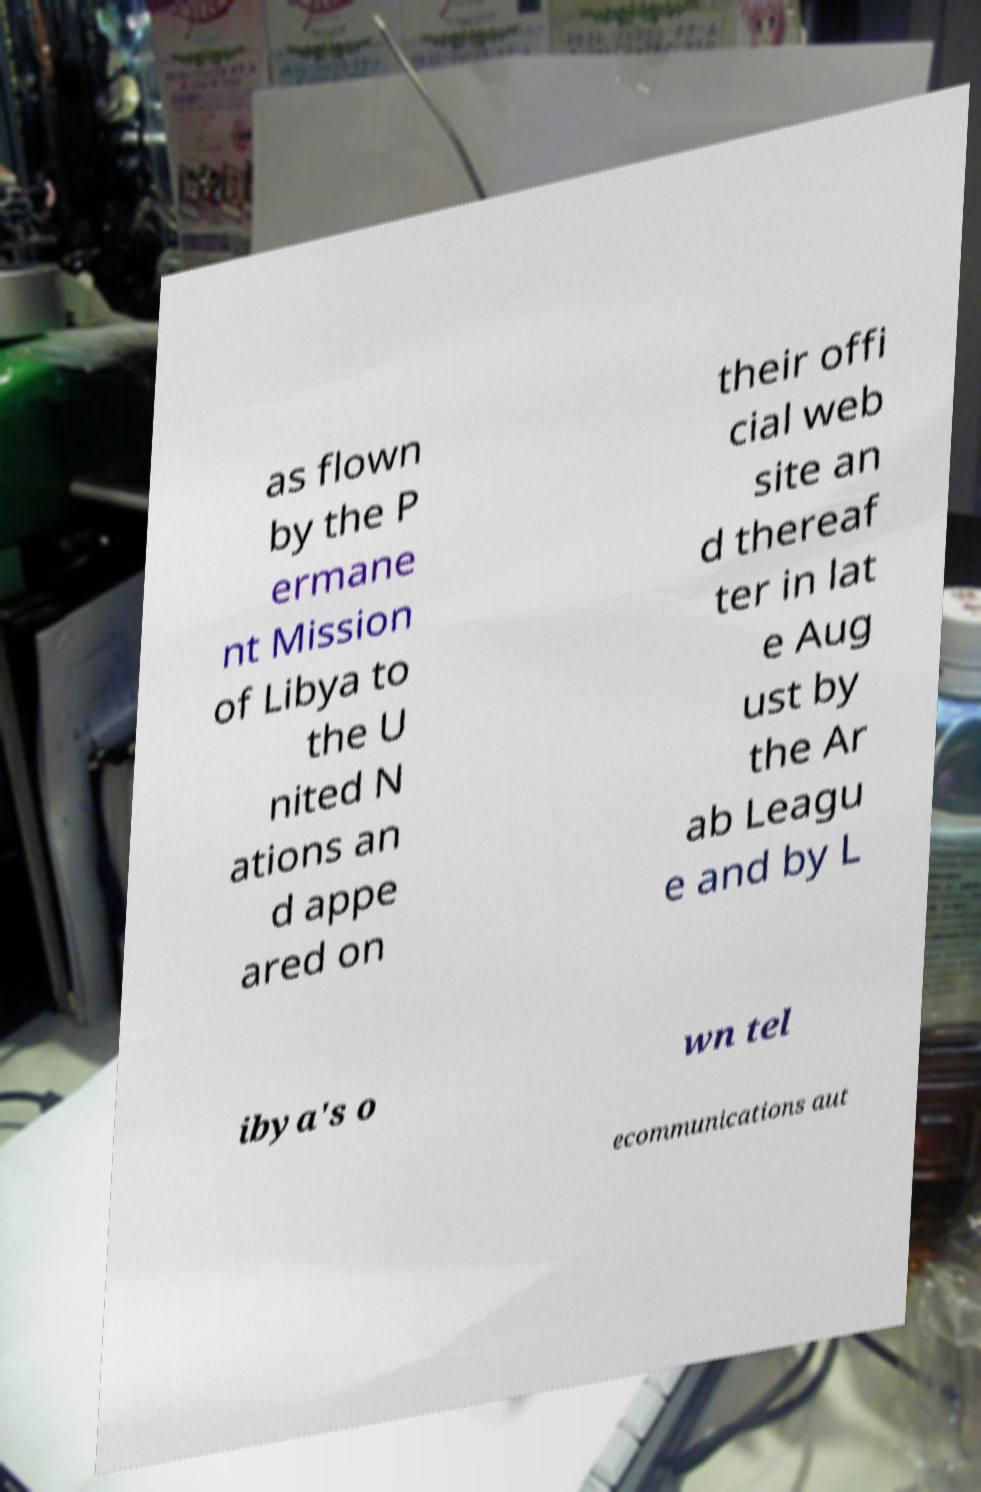Can you accurately transcribe the text from the provided image for me? as flown by the P ermane nt Mission of Libya to the U nited N ations an d appe ared on their offi cial web site an d thereaf ter in lat e Aug ust by the Ar ab Leagu e and by L ibya's o wn tel ecommunications aut 